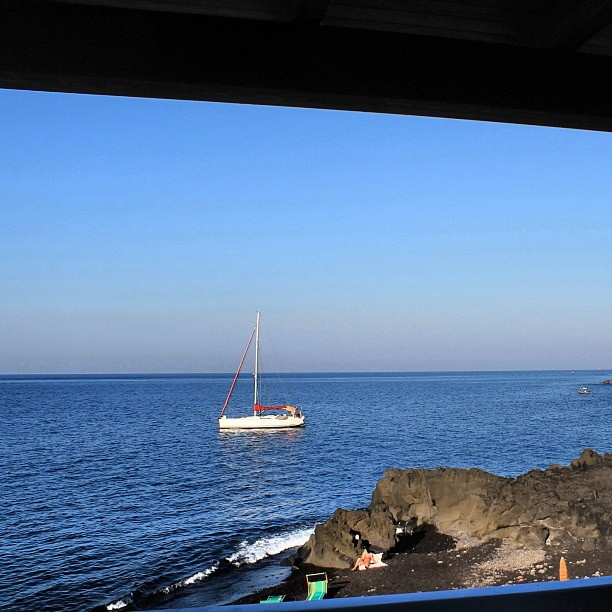Describe the objects in this image and their specific colors. I can see boat in black, gray, ivory, darkgray, and blue tones, people in black, salmon, and tan tones, boat in black, gray, darkgray, and blue tones, and people in black, tan, darkgray, gray, and ivory tones in this image. 